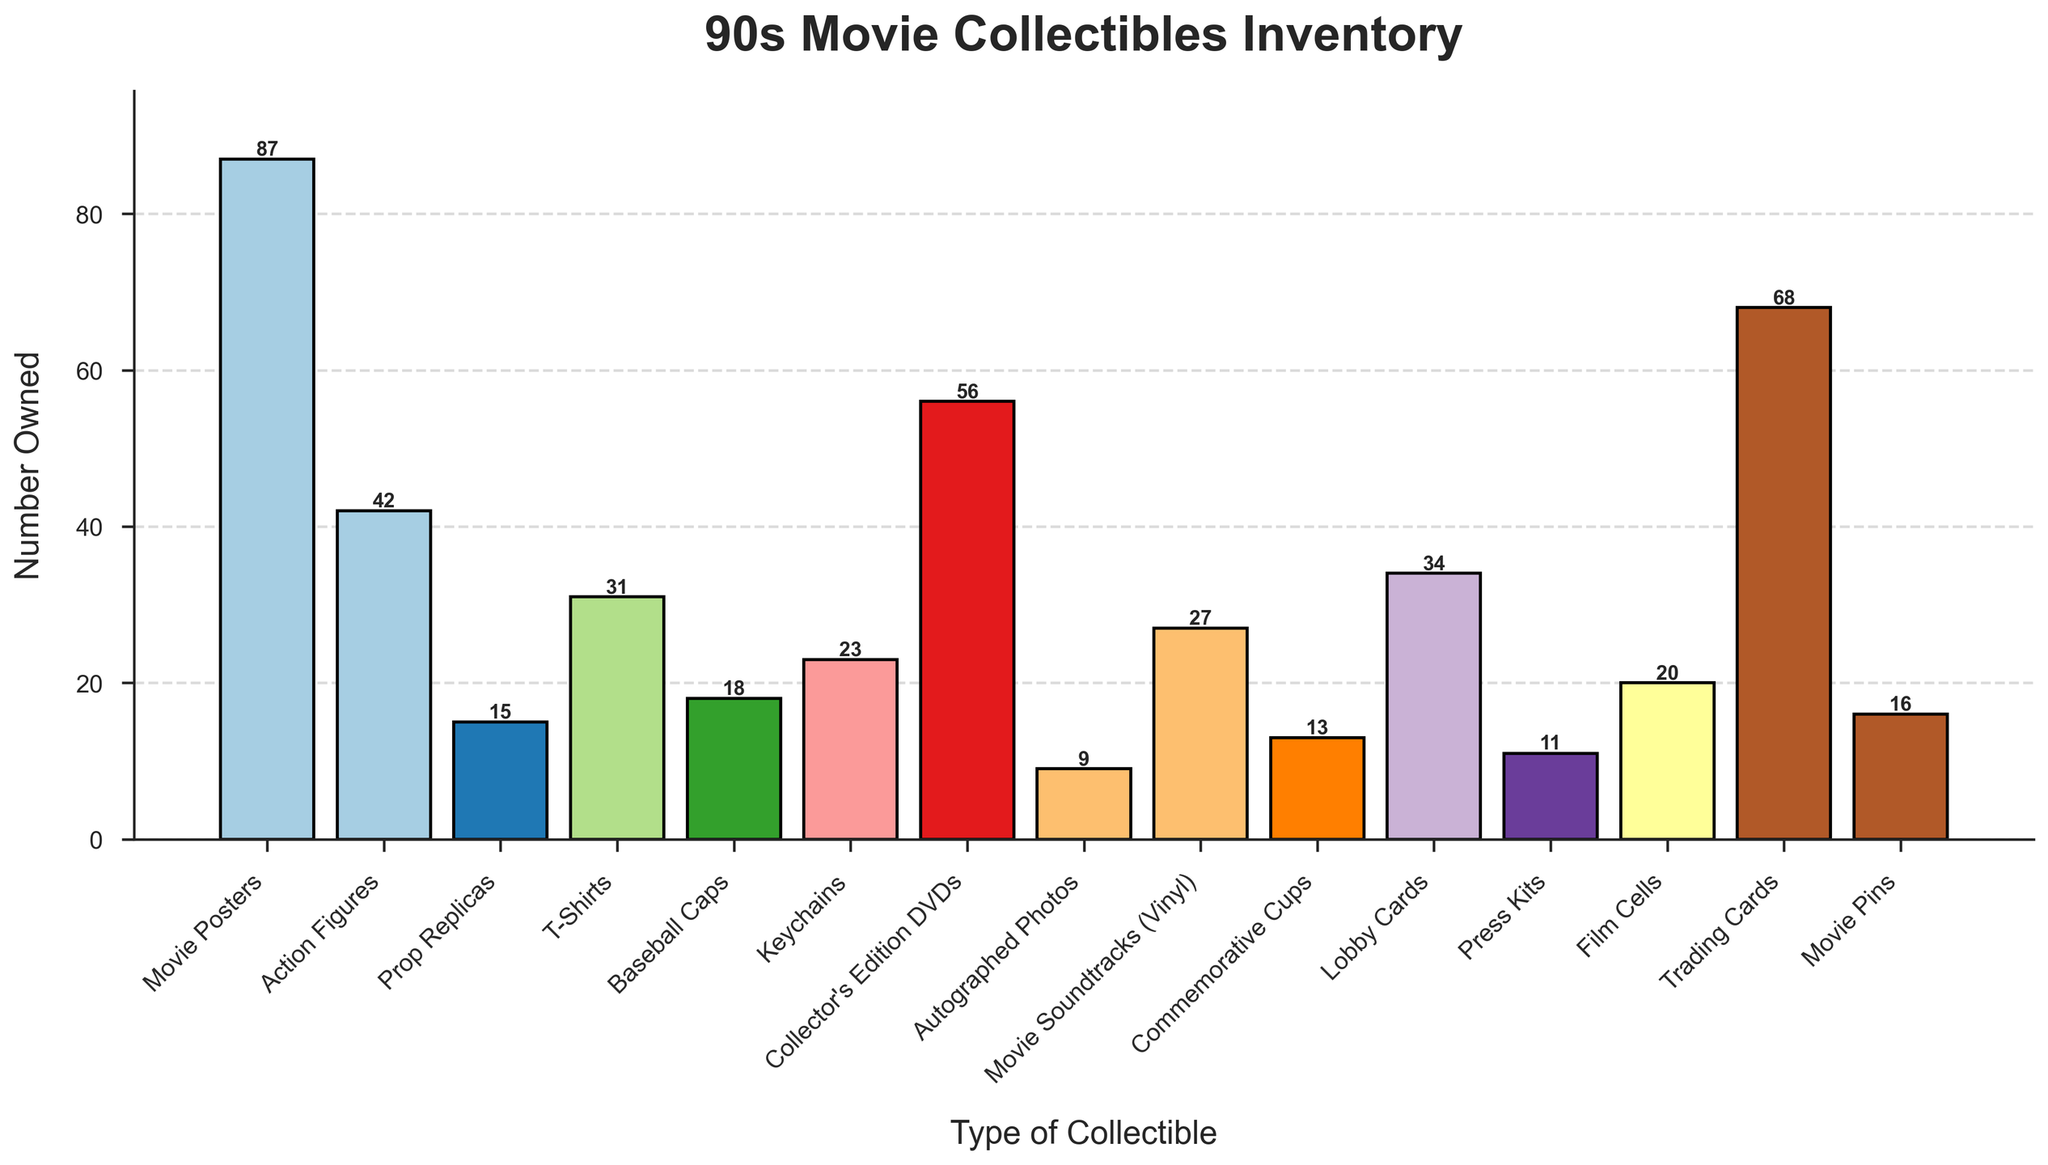What type of collectible do you own the most? To determine this, we examine the heights of the bars, and the highest bar represents the type of collectible with the highest count. The "Movie Posters" bar is the tallest at 87.
Answer: Movie Posters How many more Movie Posters do you own than Action Figures? We subtract the number of Action Figures from the number of Movie Posters: 87 (Movie Posters) - 42 (Action Figures) = 45.
Answer: 45 Which type of collectible do you own least of? To find this, we look for the shortest bar. The "Autographed Photos" bar is the shortest at 9.
Answer: Autographed Photos What's the total number of keychains, T-shirts, and movie pins combined? We add the counts for each type: 23 (Keychains) + 31 (T-Shirts) + 16 (Movie Pins) = 70.
Answer: 70 How many more Trading Cards than Baseball Caps do you own? We subtract the number of Baseball Caps from the number of Trading Cards: 68 (Trading Cards) - 18 (Baseball Caps) = 50.
Answer: 50 What is the average number of Action Figures, Film Cells, and Prop Replicas owned? We sum the counts of these collectibles and then divide by 3: (42 + 20 + 15) / 3 = 77 / 3 ≈ 25.67.
Answer: 25.67 Which two types of collectibles are closest in number owned? We compare the counts of each type to find the smallest difference. "Movie Pins" (16) and "Prop Replicas" (15) have a difference of 1.
Answer: Movie Pins and Prop Replicas How many types of collectibles do you own more than 50 items of? We count the bars with heights greater than 50: "Movie Posters" (87), "Trading Cards" (68), and "Collector's Edition DVDs" (56). There are 3 types.
Answer: 3 Which type has a higher count: Lobby Cards or Commemorative Cups? We compare the heights of the bars for Lobby Cards and Commemorative Cups. Lobby Cards (34) are higher than Commemorative Cups (13).
Answer: Lobby Cards What is the combined total of the top three most owned collectibles? We add the numbers of the top three: 87 (Movie Posters) + 68 (Trading Cards) + 56 (Collector's Edition DVDs) = 211.
Answer: 211 